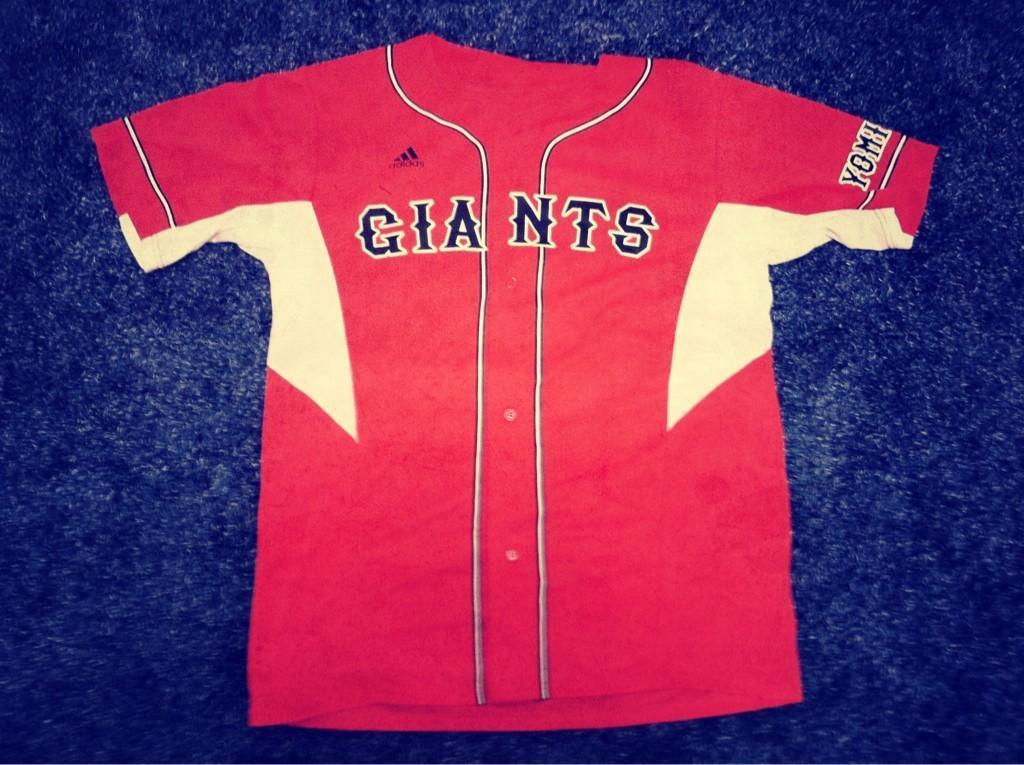<image>
Present a compact description of the photo's key features. Red and yellow Giants jersey placed on a blue background. 